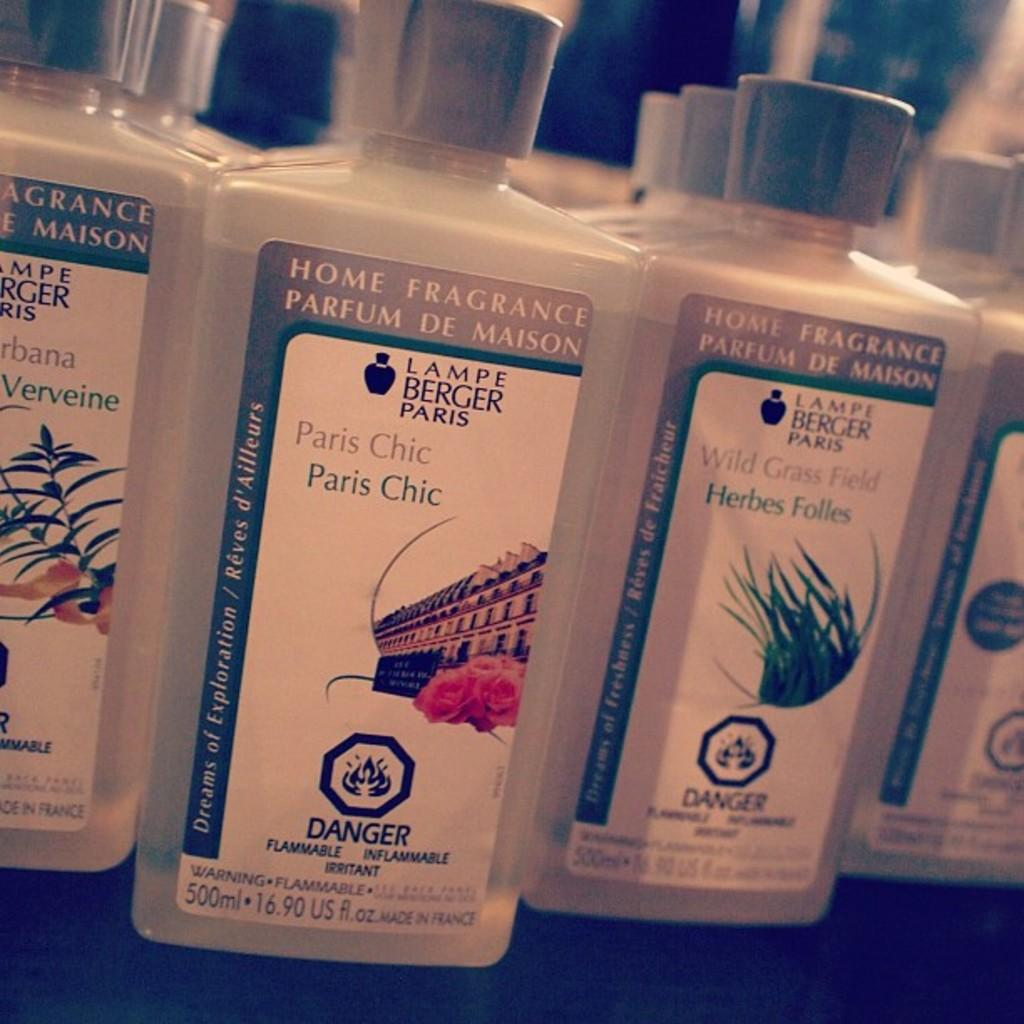Provide a one-sentence caption for the provided image. different bottles of home fragrance in 500ml bottles. 